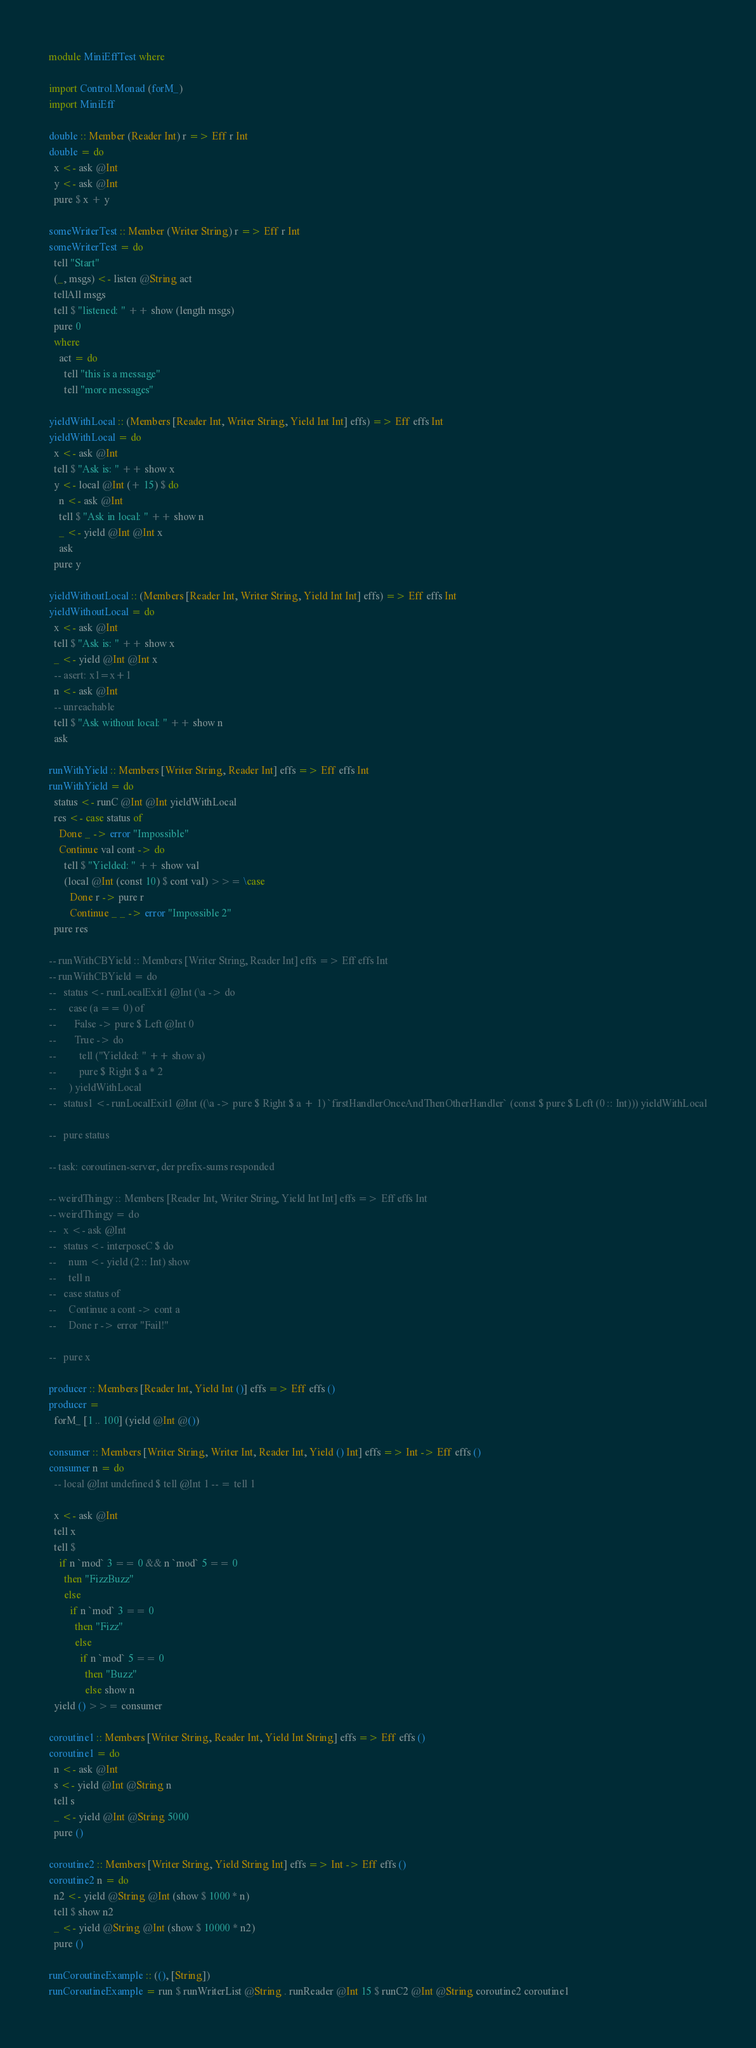Convert code to text. <code><loc_0><loc_0><loc_500><loc_500><_Haskell_>module MiniEffTest where

import Control.Monad (forM_)
import MiniEff

double :: Member (Reader Int) r => Eff r Int
double = do
  x <- ask @Int
  y <- ask @Int
  pure $ x + y

someWriterTest :: Member (Writer String) r => Eff r Int
someWriterTest = do
  tell "Start"
  (_, msgs) <- listen @String act
  tellAll msgs
  tell $ "listened: " ++ show (length msgs)
  pure 0
  where
    act = do
      tell "this is a message"
      tell "more messages"

yieldWithLocal :: (Members [Reader Int, Writer String, Yield Int Int] effs) => Eff effs Int
yieldWithLocal = do
  x <- ask @Int
  tell $ "Ask is: " ++ show x
  y <- local @Int (+ 15) $ do
    n <- ask @Int
    tell $ "Ask in local: " ++ show n
    _ <- yield @Int @Int x
    ask
  pure y

yieldWithoutLocal :: (Members [Reader Int, Writer String, Yield Int Int] effs) => Eff effs Int
yieldWithoutLocal = do
  x <- ask @Int
  tell $ "Ask is: " ++ show x
  _ <- yield @Int @Int x
  -- asert: x1=x+1
  n <- ask @Int
  -- unreachable
  tell $ "Ask without local: " ++ show n
  ask

runWithYield :: Members [Writer String, Reader Int] effs => Eff effs Int
runWithYield = do
  status <- runC @Int @Int yieldWithLocal
  res <- case status of
    Done _ -> error "Impossible"
    Continue val cont -> do
      tell $ "Yielded: " ++ show val
      (local @Int (const 10) $ cont val) >>= \case
        Done r -> pure r
        Continue _ _ -> error "Impossible 2"
  pure res

-- runWithCBYield :: Members [Writer String, Reader Int] effs => Eff effs Int
-- runWithCBYield = do
--   status <- runLocalExit1 @Int (\a -> do
--     case (a == 0) of
--       False -> pure $ Left @Int 0
--       True -> do
--         tell ("Yielded: " ++ show a)
--         pure $ Right $ a * 2
--     ) yieldWithLocal
--   status1 <- runLocalExit1 @Int ((\a -> pure $ Right $ a + 1) `firstHandlerOnceAndThenOtherHandler` (const $ pure $ Left (0 :: Int))) yieldWithLocal

--   pure status

-- task: coroutinen-server, der prefix-sums responded

-- weirdThingy :: Members [Reader Int, Writer String, Yield Int Int] effs => Eff effs Int
-- weirdThingy = do
--   x <- ask @Int
--   status <- interposeC $ do
--     num <- yield (2 :: Int) show
--     tell n
--   case status of
--     Continue a cont -> cont a
--     Done r -> error "Fail!"

--   pure x

producer :: Members [Reader Int, Yield Int ()] effs => Eff effs ()
producer =
  forM_ [1 .. 100] (yield @Int @())

consumer :: Members [Writer String, Writer Int, Reader Int, Yield () Int] effs => Int -> Eff effs ()
consumer n = do
  -- local @Int undefined $ tell @Int 1 -- = tell 1

  x <- ask @Int
  tell x
  tell $
    if n `mod` 3 == 0 && n `mod` 5 == 0
      then "FizzBuzz"
      else
        if n `mod` 3 == 0
          then "Fizz"
          else
            if n `mod` 5 == 0
              then "Buzz"
              else show n
  yield () >>= consumer

coroutine1 :: Members [Writer String, Reader Int, Yield Int String] effs => Eff effs ()
coroutine1 = do
  n <- ask @Int
  s <- yield @Int @String n
  tell s
  _ <- yield @Int @String 5000
  pure ()

coroutine2 :: Members [Writer String, Yield String Int] effs => Int -> Eff effs ()
coroutine2 n = do
  n2 <- yield @String @Int (show $ 1000 * n)
  tell $ show n2
  _ <- yield @String @Int (show $ 10000 * n2)
  pure ()

runCoroutineExample :: ((), [String])
runCoroutineExample = run $ runWriterList @String . runReader @Int 15 $ runC2 @Int @String coroutine2 coroutine1
</code> 